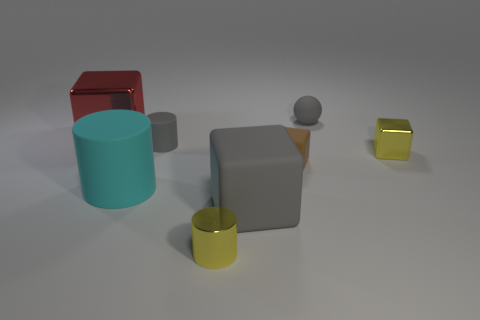There is a thing that is both behind the small rubber cylinder and to the right of the yellow metallic cylinder; what size is it? The object in question appears to be a medium-sized gray cube, located behind the small rubber cylinder and to the right of the yellow metallic cylinder as viewed from the camera's perspective. 